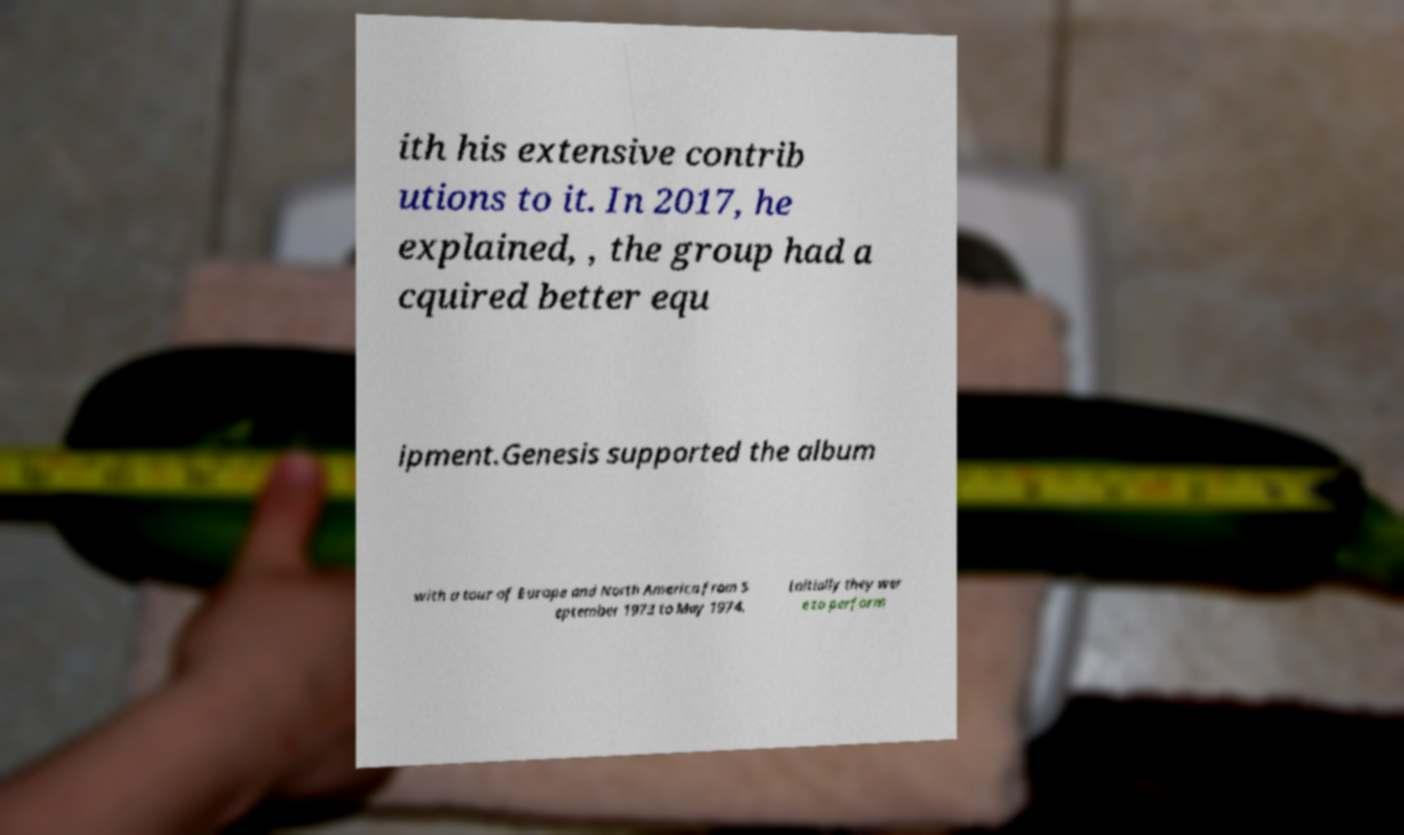Can you accurately transcribe the text from the provided image for me? ith his extensive contrib utions to it. In 2017, he explained, , the group had a cquired better equ ipment.Genesis supported the album with a tour of Europe and North America from S eptember 1973 to May 1974. Initially they wer e to perform 